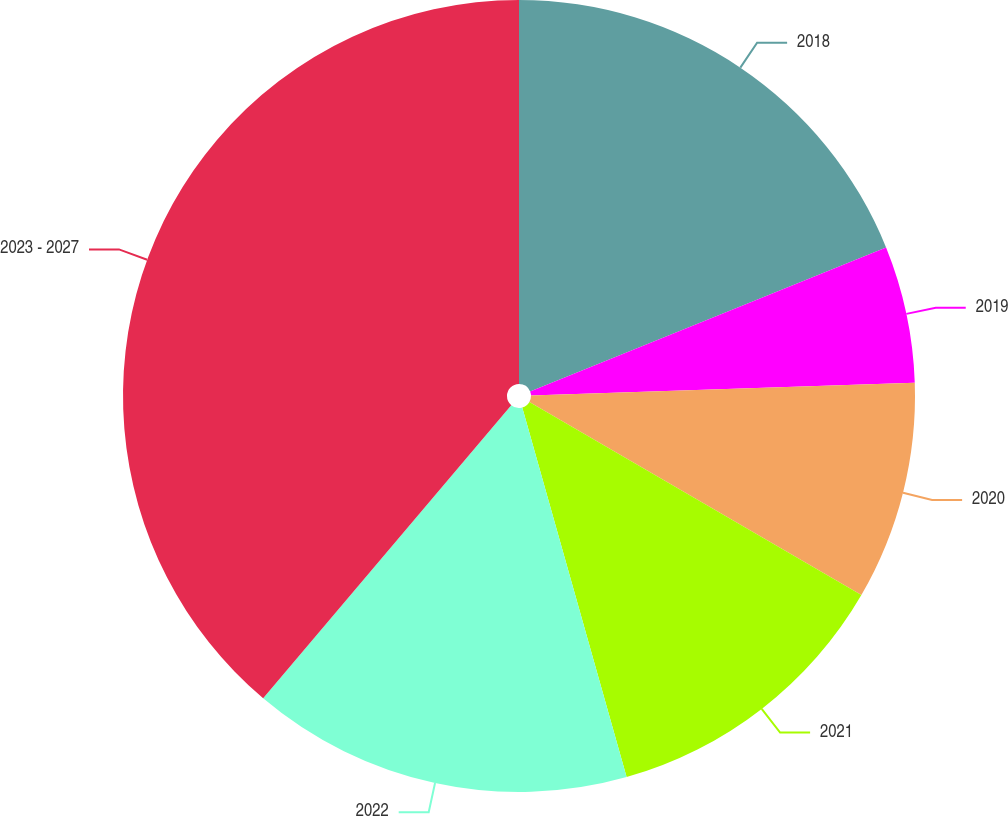<chart> <loc_0><loc_0><loc_500><loc_500><pie_chart><fcel>2018<fcel>2019<fcel>2020<fcel>2021<fcel>2022<fcel>2023 - 2027<nl><fcel>18.88%<fcel>5.59%<fcel>8.91%<fcel>12.24%<fcel>15.56%<fcel>38.82%<nl></chart> 